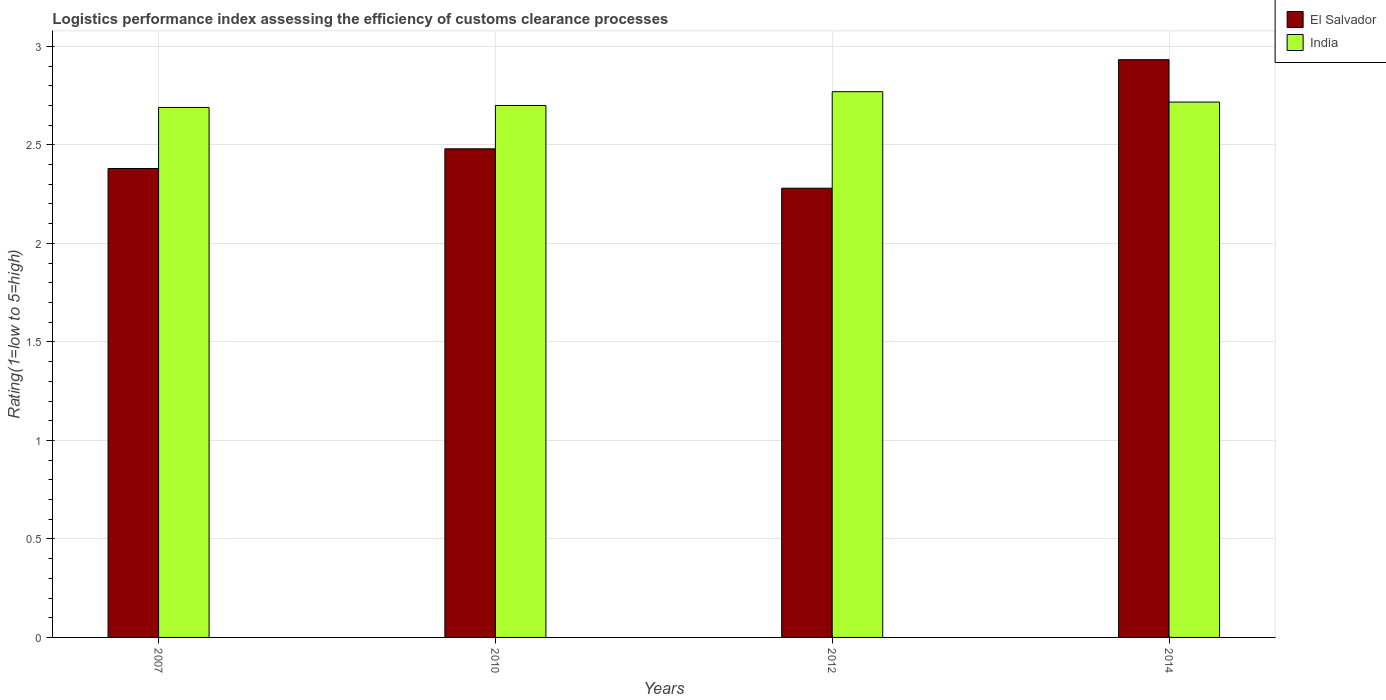How many different coloured bars are there?
Your answer should be very brief. 2. How many groups of bars are there?
Provide a short and direct response. 4. Are the number of bars on each tick of the X-axis equal?
Provide a short and direct response. Yes. What is the label of the 3rd group of bars from the left?
Provide a succinct answer. 2012. In how many cases, is the number of bars for a given year not equal to the number of legend labels?
Give a very brief answer. 0. What is the Logistic performance index in El Salvador in 2010?
Give a very brief answer. 2.48. Across all years, what is the maximum Logistic performance index in India?
Your answer should be very brief. 2.77. Across all years, what is the minimum Logistic performance index in India?
Provide a succinct answer. 2.69. In which year was the Logistic performance index in India maximum?
Provide a short and direct response. 2012. In which year was the Logistic performance index in El Salvador minimum?
Make the answer very short. 2012. What is the total Logistic performance index in El Salvador in the graph?
Offer a terse response. 10.07. What is the difference between the Logistic performance index in India in 2010 and that in 2012?
Offer a terse response. -0.07. What is the difference between the Logistic performance index in El Salvador in 2014 and the Logistic performance index in India in 2012?
Ensure brevity in your answer.  0.16. What is the average Logistic performance index in El Salvador per year?
Provide a short and direct response. 2.52. In the year 2012, what is the difference between the Logistic performance index in El Salvador and Logistic performance index in India?
Keep it short and to the point. -0.49. What is the ratio of the Logistic performance index in El Salvador in 2007 to that in 2014?
Give a very brief answer. 0.81. What is the difference between the highest and the second highest Logistic performance index in India?
Provide a short and direct response. 0.05. What is the difference between the highest and the lowest Logistic performance index in India?
Make the answer very short. 0.08. Is the sum of the Logistic performance index in El Salvador in 2007 and 2010 greater than the maximum Logistic performance index in India across all years?
Your answer should be compact. Yes. What does the 1st bar from the left in 2010 represents?
Your answer should be very brief. El Salvador. What does the 2nd bar from the right in 2012 represents?
Ensure brevity in your answer.  El Salvador. Are all the bars in the graph horizontal?
Ensure brevity in your answer.  No. How many years are there in the graph?
Your answer should be compact. 4. What is the difference between two consecutive major ticks on the Y-axis?
Provide a succinct answer. 0.5. Are the values on the major ticks of Y-axis written in scientific E-notation?
Your answer should be compact. No. Does the graph contain any zero values?
Give a very brief answer. No. Does the graph contain grids?
Provide a succinct answer. Yes. How are the legend labels stacked?
Keep it short and to the point. Vertical. What is the title of the graph?
Your response must be concise. Logistics performance index assessing the efficiency of customs clearance processes. What is the label or title of the X-axis?
Provide a short and direct response. Years. What is the label or title of the Y-axis?
Make the answer very short. Rating(1=low to 5=high). What is the Rating(1=low to 5=high) in El Salvador in 2007?
Provide a succinct answer. 2.38. What is the Rating(1=low to 5=high) in India in 2007?
Offer a terse response. 2.69. What is the Rating(1=low to 5=high) in El Salvador in 2010?
Offer a very short reply. 2.48. What is the Rating(1=low to 5=high) in El Salvador in 2012?
Provide a succinct answer. 2.28. What is the Rating(1=low to 5=high) in India in 2012?
Your answer should be compact. 2.77. What is the Rating(1=low to 5=high) of El Salvador in 2014?
Give a very brief answer. 2.93. What is the Rating(1=low to 5=high) of India in 2014?
Provide a short and direct response. 2.72. Across all years, what is the maximum Rating(1=low to 5=high) of El Salvador?
Your answer should be very brief. 2.93. Across all years, what is the maximum Rating(1=low to 5=high) of India?
Your answer should be compact. 2.77. Across all years, what is the minimum Rating(1=low to 5=high) of El Salvador?
Your answer should be very brief. 2.28. Across all years, what is the minimum Rating(1=low to 5=high) of India?
Your answer should be very brief. 2.69. What is the total Rating(1=low to 5=high) of El Salvador in the graph?
Your response must be concise. 10.07. What is the total Rating(1=low to 5=high) of India in the graph?
Offer a very short reply. 10.88. What is the difference between the Rating(1=low to 5=high) in El Salvador in 2007 and that in 2010?
Provide a succinct answer. -0.1. What is the difference between the Rating(1=low to 5=high) of India in 2007 and that in 2010?
Offer a very short reply. -0.01. What is the difference between the Rating(1=low to 5=high) of India in 2007 and that in 2012?
Provide a succinct answer. -0.08. What is the difference between the Rating(1=low to 5=high) of El Salvador in 2007 and that in 2014?
Offer a very short reply. -0.55. What is the difference between the Rating(1=low to 5=high) in India in 2007 and that in 2014?
Offer a very short reply. -0.03. What is the difference between the Rating(1=low to 5=high) of India in 2010 and that in 2012?
Your response must be concise. -0.07. What is the difference between the Rating(1=low to 5=high) in El Salvador in 2010 and that in 2014?
Give a very brief answer. -0.45. What is the difference between the Rating(1=low to 5=high) of India in 2010 and that in 2014?
Provide a short and direct response. -0.02. What is the difference between the Rating(1=low to 5=high) of El Salvador in 2012 and that in 2014?
Make the answer very short. -0.65. What is the difference between the Rating(1=low to 5=high) in India in 2012 and that in 2014?
Your response must be concise. 0.05. What is the difference between the Rating(1=low to 5=high) in El Salvador in 2007 and the Rating(1=low to 5=high) in India in 2010?
Keep it short and to the point. -0.32. What is the difference between the Rating(1=low to 5=high) of El Salvador in 2007 and the Rating(1=low to 5=high) of India in 2012?
Ensure brevity in your answer.  -0.39. What is the difference between the Rating(1=low to 5=high) in El Salvador in 2007 and the Rating(1=low to 5=high) in India in 2014?
Ensure brevity in your answer.  -0.34. What is the difference between the Rating(1=low to 5=high) in El Salvador in 2010 and the Rating(1=low to 5=high) in India in 2012?
Make the answer very short. -0.29. What is the difference between the Rating(1=low to 5=high) in El Salvador in 2010 and the Rating(1=low to 5=high) in India in 2014?
Your response must be concise. -0.24. What is the difference between the Rating(1=low to 5=high) of El Salvador in 2012 and the Rating(1=low to 5=high) of India in 2014?
Ensure brevity in your answer.  -0.44. What is the average Rating(1=low to 5=high) of El Salvador per year?
Give a very brief answer. 2.52. What is the average Rating(1=low to 5=high) in India per year?
Keep it short and to the point. 2.72. In the year 2007, what is the difference between the Rating(1=low to 5=high) in El Salvador and Rating(1=low to 5=high) in India?
Provide a short and direct response. -0.31. In the year 2010, what is the difference between the Rating(1=low to 5=high) in El Salvador and Rating(1=low to 5=high) in India?
Make the answer very short. -0.22. In the year 2012, what is the difference between the Rating(1=low to 5=high) of El Salvador and Rating(1=low to 5=high) of India?
Offer a very short reply. -0.49. In the year 2014, what is the difference between the Rating(1=low to 5=high) of El Salvador and Rating(1=low to 5=high) of India?
Ensure brevity in your answer.  0.21. What is the ratio of the Rating(1=low to 5=high) in El Salvador in 2007 to that in 2010?
Your answer should be compact. 0.96. What is the ratio of the Rating(1=low to 5=high) of El Salvador in 2007 to that in 2012?
Make the answer very short. 1.04. What is the ratio of the Rating(1=low to 5=high) in India in 2007 to that in 2012?
Offer a very short reply. 0.97. What is the ratio of the Rating(1=low to 5=high) of El Salvador in 2007 to that in 2014?
Offer a terse response. 0.81. What is the ratio of the Rating(1=low to 5=high) in El Salvador in 2010 to that in 2012?
Your response must be concise. 1.09. What is the ratio of the Rating(1=low to 5=high) in India in 2010 to that in 2012?
Offer a terse response. 0.97. What is the ratio of the Rating(1=low to 5=high) of El Salvador in 2010 to that in 2014?
Provide a short and direct response. 0.85. What is the ratio of the Rating(1=low to 5=high) of El Salvador in 2012 to that in 2014?
Ensure brevity in your answer.  0.78. What is the ratio of the Rating(1=low to 5=high) in India in 2012 to that in 2014?
Offer a very short reply. 1.02. What is the difference between the highest and the second highest Rating(1=low to 5=high) in El Salvador?
Provide a short and direct response. 0.45. What is the difference between the highest and the second highest Rating(1=low to 5=high) of India?
Your answer should be compact. 0.05. What is the difference between the highest and the lowest Rating(1=low to 5=high) of El Salvador?
Make the answer very short. 0.65. What is the difference between the highest and the lowest Rating(1=low to 5=high) of India?
Provide a succinct answer. 0.08. 